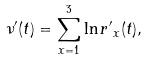Convert formula to latex. <formula><loc_0><loc_0><loc_500><loc_500>\nu \rq ( t ) = \sum _ { x = 1 } ^ { 3 } \ln { r \rq } _ { x } ( t ) ,</formula> 